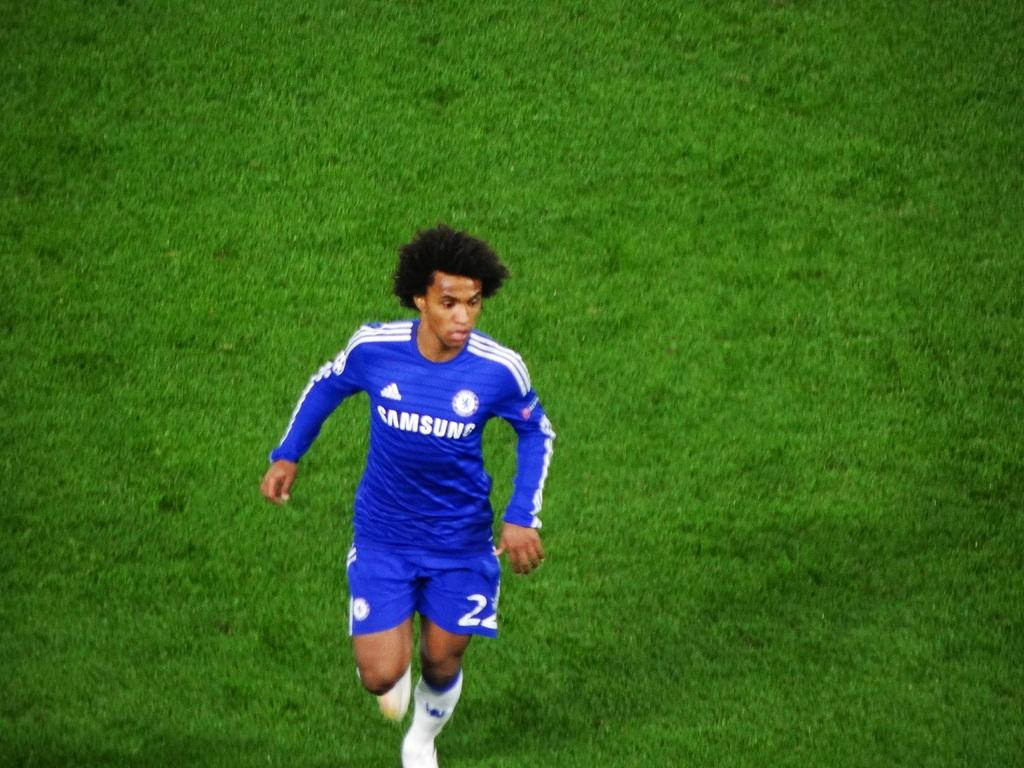<image>
Relay a brief, clear account of the picture shown. A young athlete runs across the field in his blue Samsung shirt 